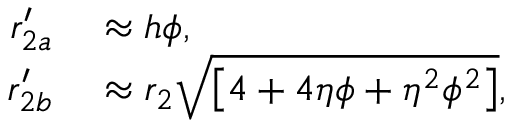<formula> <loc_0><loc_0><loc_500><loc_500>\begin{array} { r l } { r _ { 2 a } ^ { \prime } } & \approx h \phi , } \\ { r _ { 2 b } ^ { \prime } } & \approx r _ { 2 } \sqrt { \left [ 4 + 4 \eta \phi + \eta ^ { 2 } \phi ^ { 2 } \right ] } , } \end{array}</formula> 